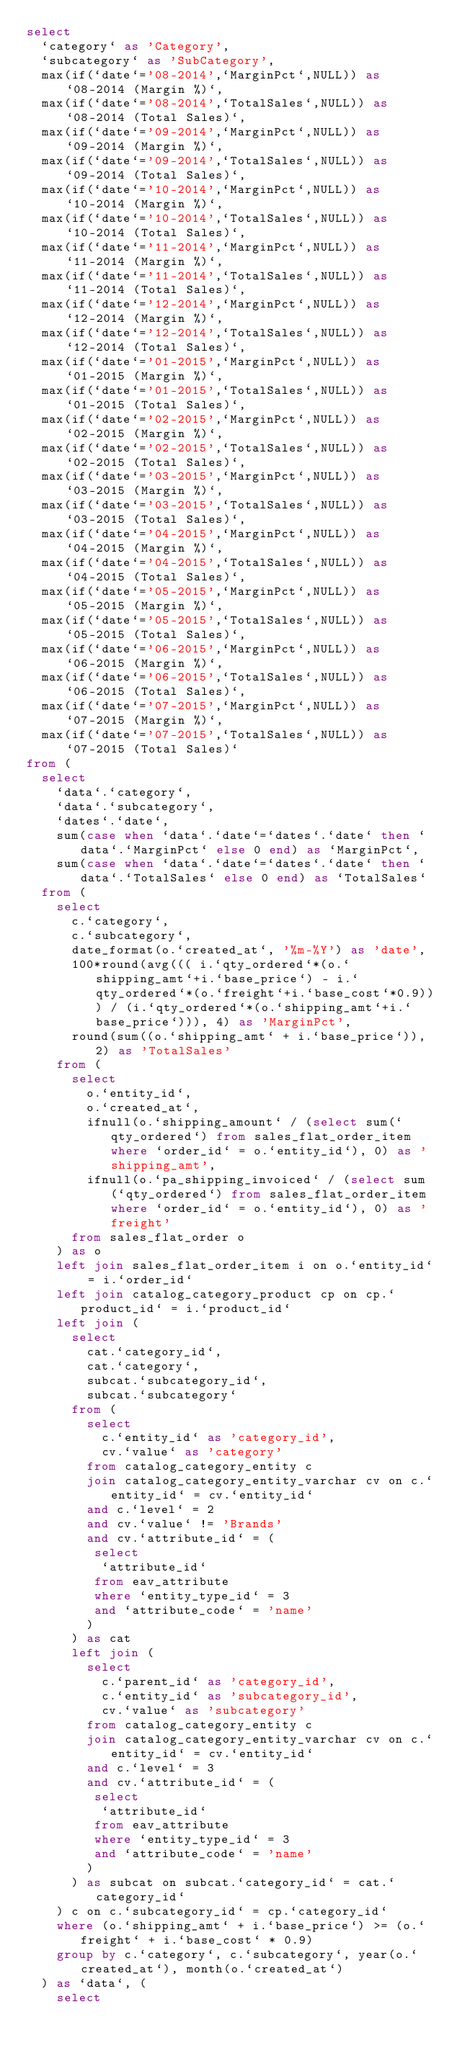<code> <loc_0><loc_0><loc_500><loc_500><_SQL_>select
  `category` as 'Category',
  `subcategory` as 'SubCategory',
  max(if(`date`='08-2014',`MarginPct`,NULL)) as `08-2014 (Margin %)`,
  max(if(`date`='08-2014',`TotalSales`,NULL)) as `08-2014 (Total Sales)`,
  max(if(`date`='09-2014',`MarginPct`,NULL)) as `09-2014 (Margin %)`,
  max(if(`date`='09-2014',`TotalSales`,NULL)) as `09-2014 (Total Sales)`,
  max(if(`date`='10-2014',`MarginPct`,NULL)) as `10-2014 (Margin %)`,
  max(if(`date`='10-2014',`TotalSales`,NULL)) as `10-2014 (Total Sales)`,
  max(if(`date`='11-2014',`MarginPct`,NULL)) as `11-2014 (Margin %)`,
  max(if(`date`='11-2014',`TotalSales`,NULL)) as `11-2014 (Total Sales)`,
  max(if(`date`='12-2014',`MarginPct`,NULL)) as `12-2014 (Margin %)`,
  max(if(`date`='12-2014',`TotalSales`,NULL)) as `12-2014 (Total Sales)`,
  max(if(`date`='01-2015',`MarginPct`,NULL)) as `01-2015 (Margin %)`,
  max(if(`date`='01-2015',`TotalSales`,NULL)) as `01-2015 (Total Sales)`,
  max(if(`date`='02-2015',`MarginPct`,NULL)) as `02-2015 (Margin %)`,
  max(if(`date`='02-2015',`TotalSales`,NULL)) as `02-2015 (Total Sales)`,
  max(if(`date`='03-2015',`MarginPct`,NULL)) as `03-2015 (Margin %)`,
  max(if(`date`='03-2015',`TotalSales`,NULL)) as `03-2015 (Total Sales)`,
  max(if(`date`='04-2015',`MarginPct`,NULL)) as `04-2015 (Margin %)`,
  max(if(`date`='04-2015',`TotalSales`,NULL)) as `04-2015 (Total Sales)`,
  max(if(`date`='05-2015',`MarginPct`,NULL)) as `05-2015 (Margin %)`,
  max(if(`date`='05-2015',`TotalSales`,NULL)) as `05-2015 (Total Sales)`,
  max(if(`date`='06-2015',`MarginPct`,NULL)) as `06-2015 (Margin %)`,
  max(if(`date`='06-2015',`TotalSales`,NULL)) as `06-2015 (Total Sales)`,
  max(if(`date`='07-2015',`MarginPct`,NULL)) as `07-2015 (Margin %)`,
  max(if(`date`='07-2015',`TotalSales`,NULL)) as `07-2015 (Total Sales)`
from (
  select
    `data`.`category`,
    `data`.`subcategory`,
    `dates`.`date`,
    sum(case when `data`.`date`=`dates`.`date` then `data`.`MarginPct` else 0 end) as `MarginPct`,
    sum(case when `data`.`date`=`dates`.`date` then `data`.`TotalSales` else 0 end) as `TotalSales`
  from (
    select
      c.`category`,
      c.`subcategory`,
      date_format(o.`created_at`, '%m-%Y') as 'date',
      100*round(avg((( i.`qty_ordered`*(o.`shipping_amt`+i.`base_price`) - i.`qty_ordered`*(o.`freight`+i.`base_cost`*0.9))) / (i.`qty_ordered`*(o.`shipping_amt`+i.`base_price`))), 4) as 'MarginPct',
      round(sum((o.`shipping_amt` + i.`base_price`)), 2) as 'TotalSales'
    from (
      select
        o.`entity_id`,
        o.`created_at`,
        ifnull(o.`shipping_amount` / (select sum(`qty_ordered`) from sales_flat_order_item where `order_id` = o.`entity_id`), 0) as 'shipping_amt',
        ifnull(o.`pa_shipping_invoiced` / (select sum(`qty_ordered`) from sales_flat_order_item where `order_id` = o.`entity_id`), 0) as 'freight'
      from sales_flat_order o
    ) as o
    left join sales_flat_order_item i on o.`entity_id` = i.`order_id`
    left join catalog_category_product cp on cp.`product_id` = i.`product_id`
    left join (
      select
        cat.`category_id`,
        cat.`category`,
        subcat.`subcategory_id`,
        subcat.`subcategory`
      from (
        select
          c.`entity_id` as 'category_id',
          cv.`value` as 'category'
        from catalog_category_entity c
        join catalog_category_entity_varchar cv on c.`entity_id` = cv.`entity_id`
        and c.`level` = 2
        and cv.`value` != 'Brands'
        and cv.`attribute_id` = (
         select
          `attribute_id`
         from eav_attribute
         where `entity_type_id` = 3
         and `attribute_code` = 'name'
        )
      ) as cat
      left join (
        select
          c.`parent_id` as 'category_id',
          c.`entity_id` as 'subcategory_id',
          cv.`value` as 'subcategory'
        from catalog_category_entity c
        join catalog_category_entity_varchar cv on c.`entity_id` = cv.`entity_id`
        and c.`level` = 3
        and cv.`attribute_id` = (
         select
          `attribute_id`
         from eav_attribute
         where `entity_type_id` = 3
         and `attribute_code` = 'name'
        )
      ) as subcat on subcat.`category_id` = cat.`category_id`
    ) c on c.`subcategory_id` = cp.`category_id`
    where (o.`shipping_amt` + i.`base_price`) >= (o.`freight` + i.`base_cost` * 0.9)
    group by c.`category`, c.`subcategory`, year(o.`created_at`), month(o.`created_at`)
  ) as `data`, (
    select</code> 